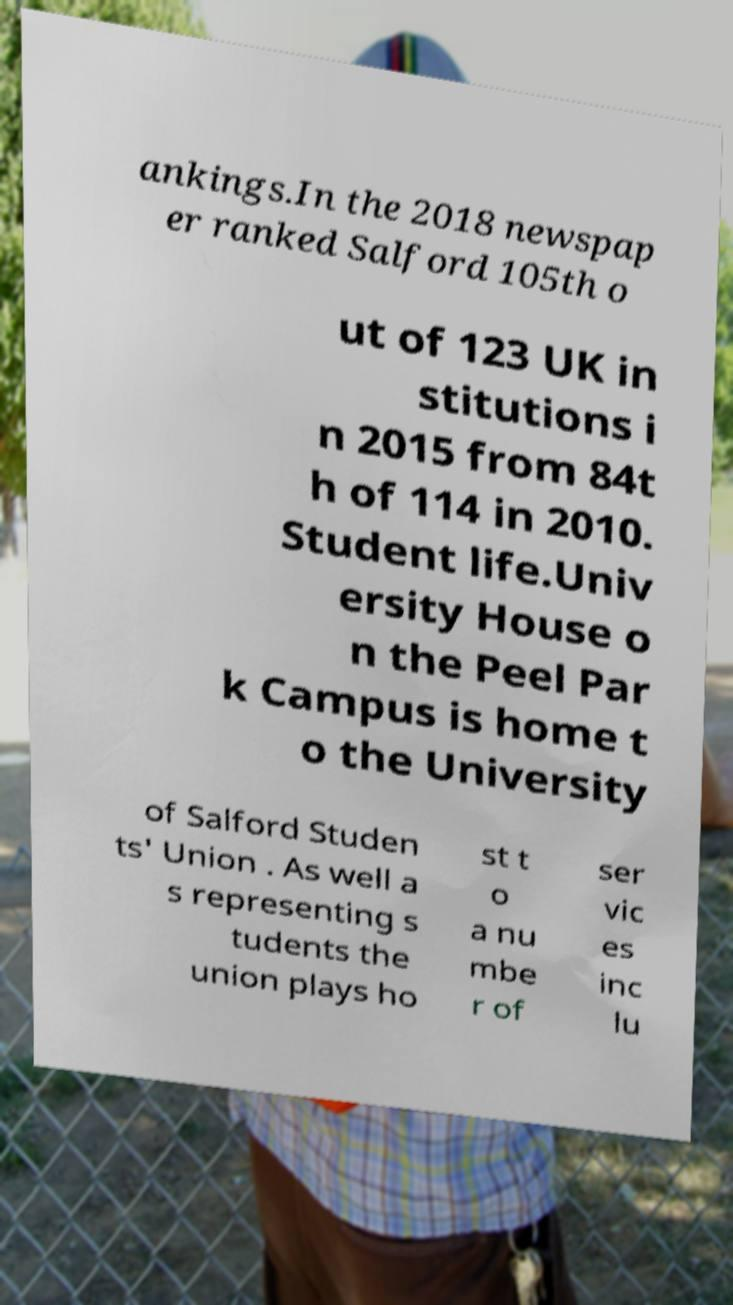There's text embedded in this image that I need extracted. Can you transcribe it verbatim? ankings.In the 2018 newspap er ranked Salford 105th o ut of 123 UK in stitutions i n 2015 from 84t h of 114 in 2010. Student life.Univ ersity House o n the Peel Par k Campus is home t o the University of Salford Studen ts' Union . As well a s representing s tudents the union plays ho st t o a nu mbe r of ser vic es inc lu 